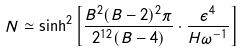<formula> <loc_0><loc_0><loc_500><loc_500>N \simeq \sinh ^ { 2 } \left [ \frac { B ^ { 2 } ( B - 2 ) ^ { 2 } \pi } { 2 ^ { 1 2 } ( B - 4 ) } \cdot \frac { \epsilon ^ { 4 } } { H \omega ^ { - 1 } } \right ]</formula> 